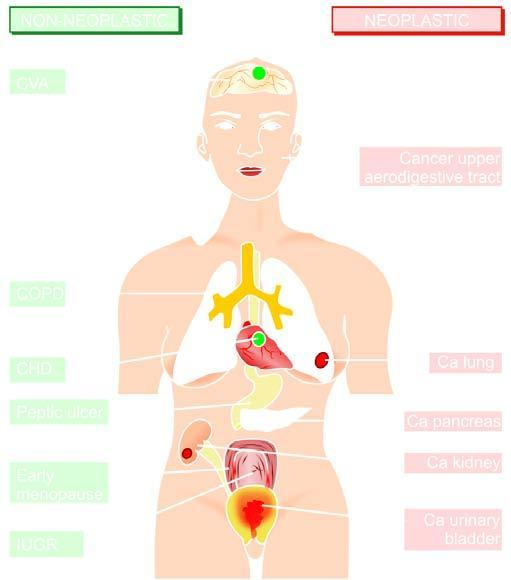does right side show smoking-related neoplastic diseases while left side indicates non-neoplastic diseases associated with smoking, numbered serially in order of frequency of occurrence?
Answer the question using a single word or phrase. Yes 